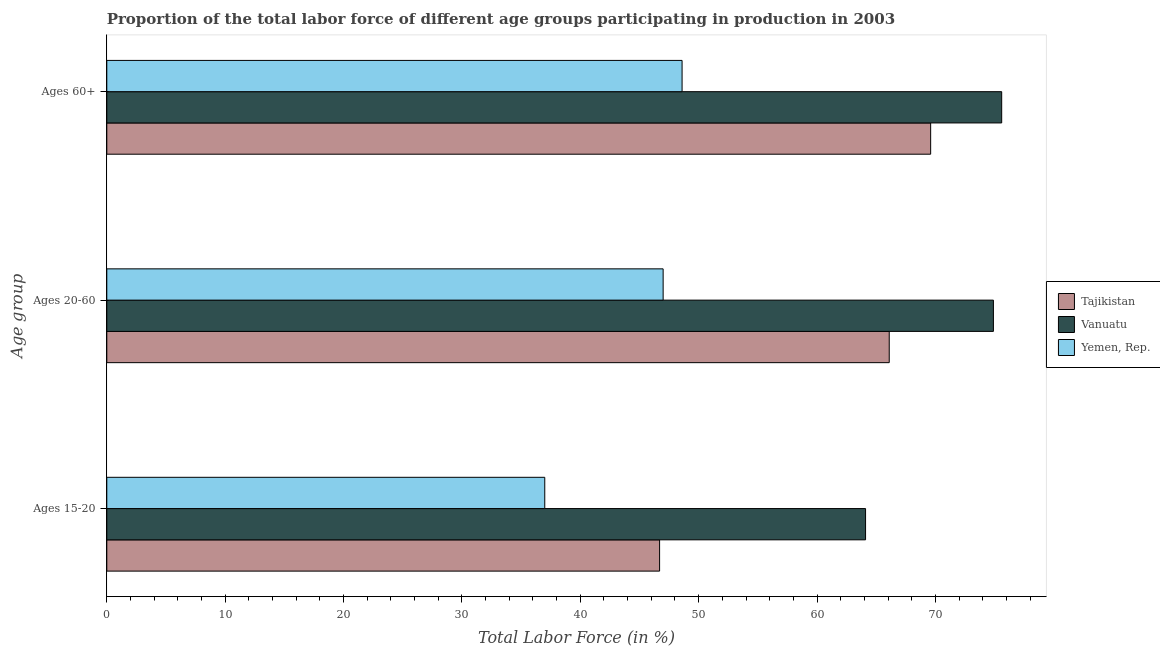How many different coloured bars are there?
Your response must be concise. 3. How many groups of bars are there?
Your answer should be compact. 3. What is the label of the 3rd group of bars from the top?
Ensure brevity in your answer.  Ages 15-20. What is the percentage of labor force above age 60 in Vanuatu?
Offer a terse response. 75.6. Across all countries, what is the maximum percentage of labor force within the age group 20-60?
Give a very brief answer. 74.9. Across all countries, what is the minimum percentage of labor force within the age group 20-60?
Give a very brief answer. 47. In which country was the percentage of labor force within the age group 20-60 maximum?
Offer a very short reply. Vanuatu. In which country was the percentage of labor force above age 60 minimum?
Provide a short and direct response. Yemen, Rep. What is the total percentage of labor force within the age group 20-60 in the graph?
Make the answer very short. 188. What is the difference between the percentage of labor force within the age group 15-20 in Tajikistan and that in Yemen, Rep.?
Your answer should be compact. 9.7. What is the difference between the percentage of labor force within the age group 20-60 in Yemen, Rep. and the percentage of labor force above age 60 in Vanuatu?
Provide a succinct answer. -28.6. What is the average percentage of labor force within the age group 15-20 per country?
Keep it short and to the point. 49.27. What is the difference between the percentage of labor force within the age group 15-20 and percentage of labor force within the age group 20-60 in Vanuatu?
Give a very brief answer. -10.8. In how many countries, is the percentage of labor force above age 60 greater than 62 %?
Your answer should be compact. 2. What is the ratio of the percentage of labor force above age 60 in Yemen, Rep. to that in Tajikistan?
Keep it short and to the point. 0.7. Is the percentage of labor force within the age group 20-60 in Yemen, Rep. less than that in Vanuatu?
Offer a terse response. Yes. What is the difference between the highest and the second highest percentage of labor force within the age group 20-60?
Your answer should be compact. 8.8. What is the difference between the highest and the lowest percentage of labor force within the age group 15-20?
Offer a terse response. 27.1. What does the 3rd bar from the top in Ages 20-60 represents?
Your answer should be very brief. Tajikistan. What does the 3rd bar from the bottom in Ages 20-60 represents?
Your answer should be very brief. Yemen, Rep. Is it the case that in every country, the sum of the percentage of labor force within the age group 15-20 and percentage of labor force within the age group 20-60 is greater than the percentage of labor force above age 60?
Your answer should be compact. Yes. How many countries are there in the graph?
Your response must be concise. 3. What is the difference between two consecutive major ticks on the X-axis?
Give a very brief answer. 10. Are the values on the major ticks of X-axis written in scientific E-notation?
Your response must be concise. No. Does the graph contain grids?
Your answer should be compact. No. How many legend labels are there?
Offer a terse response. 3. How are the legend labels stacked?
Keep it short and to the point. Vertical. What is the title of the graph?
Your answer should be compact. Proportion of the total labor force of different age groups participating in production in 2003. What is the label or title of the Y-axis?
Make the answer very short. Age group. What is the Total Labor Force (in %) of Tajikistan in Ages 15-20?
Provide a succinct answer. 46.7. What is the Total Labor Force (in %) of Vanuatu in Ages 15-20?
Keep it short and to the point. 64.1. What is the Total Labor Force (in %) in Tajikistan in Ages 20-60?
Provide a short and direct response. 66.1. What is the Total Labor Force (in %) of Vanuatu in Ages 20-60?
Give a very brief answer. 74.9. What is the Total Labor Force (in %) in Yemen, Rep. in Ages 20-60?
Your answer should be compact. 47. What is the Total Labor Force (in %) in Tajikistan in Ages 60+?
Your response must be concise. 69.6. What is the Total Labor Force (in %) in Vanuatu in Ages 60+?
Give a very brief answer. 75.6. What is the Total Labor Force (in %) in Yemen, Rep. in Ages 60+?
Your answer should be compact. 48.6. Across all Age group, what is the maximum Total Labor Force (in %) in Tajikistan?
Give a very brief answer. 69.6. Across all Age group, what is the maximum Total Labor Force (in %) in Vanuatu?
Your response must be concise. 75.6. Across all Age group, what is the maximum Total Labor Force (in %) in Yemen, Rep.?
Ensure brevity in your answer.  48.6. Across all Age group, what is the minimum Total Labor Force (in %) of Tajikistan?
Provide a succinct answer. 46.7. Across all Age group, what is the minimum Total Labor Force (in %) in Vanuatu?
Offer a terse response. 64.1. Across all Age group, what is the minimum Total Labor Force (in %) in Yemen, Rep.?
Your answer should be compact. 37. What is the total Total Labor Force (in %) in Tajikistan in the graph?
Offer a very short reply. 182.4. What is the total Total Labor Force (in %) in Vanuatu in the graph?
Give a very brief answer. 214.6. What is the total Total Labor Force (in %) in Yemen, Rep. in the graph?
Offer a very short reply. 132.6. What is the difference between the Total Labor Force (in %) in Tajikistan in Ages 15-20 and that in Ages 20-60?
Provide a succinct answer. -19.4. What is the difference between the Total Labor Force (in %) of Tajikistan in Ages 15-20 and that in Ages 60+?
Your response must be concise. -22.9. What is the difference between the Total Labor Force (in %) of Vanuatu in Ages 15-20 and that in Ages 60+?
Ensure brevity in your answer.  -11.5. What is the difference between the Total Labor Force (in %) in Yemen, Rep. in Ages 15-20 and that in Ages 60+?
Provide a succinct answer. -11.6. What is the difference between the Total Labor Force (in %) in Tajikistan in Ages 15-20 and the Total Labor Force (in %) in Vanuatu in Ages 20-60?
Keep it short and to the point. -28.2. What is the difference between the Total Labor Force (in %) in Tajikistan in Ages 15-20 and the Total Labor Force (in %) in Yemen, Rep. in Ages 20-60?
Keep it short and to the point. -0.3. What is the difference between the Total Labor Force (in %) of Tajikistan in Ages 15-20 and the Total Labor Force (in %) of Vanuatu in Ages 60+?
Your answer should be compact. -28.9. What is the difference between the Total Labor Force (in %) of Vanuatu in Ages 15-20 and the Total Labor Force (in %) of Yemen, Rep. in Ages 60+?
Provide a succinct answer. 15.5. What is the difference between the Total Labor Force (in %) of Vanuatu in Ages 20-60 and the Total Labor Force (in %) of Yemen, Rep. in Ages 60+?
Offer a terse response. 26.3. What is the average Total Labor Force (in %) in Tajikistan per Age group?
Provide a succinct answer. 60.8. What is the average Total Labor Force (in %) in Vanuatu per Age group?
Your answer should be very brief. 71.53. What is the average Total Labor Force (in %) in Yemen, Rep. per Age group?
Provide a short and direct response. 44.2. What is the difference between the Total Labor Force (in %) in Tajikistan and Total Labor Force (in %) in Vanuatu in Ages 15-20?
Provide a succinct answer. -17.4. What is the difference between the Total Labor Force (in %) in Tajikistan and Total Labor Force (in %) in Yemen, Rep. in Ages 15-20?
Provide a succinct answer. 9.7. What is the difference between the Total Labor Force (in %) in Vanuatu and Total Labor Force (in %) in Yemen, Rep. in Ages 15-20?
Keep it short and to the point. 27.1. What is the difference between the Total Labor Force (in %) in Vanuatu and Total Labor Force (in %) in Yemen, Rep. in Ages 20-60?
Ensure brevity in your answer.  27.9. What is the difference between the Total Labor Force (in %) in Tajikistan and Total Labor Force (in %) in Vanuatu in Ages 60+?
Ensure brevity in your answer.  -6. What is the difference between the Total Labor Force (in %) of Tajikistan and Total Labor Force (in %) of Yemen, Rep. in Ages 60+?
Provide a succinct answer. 21. What is the ratio of the Total Labor Force (in %) in Tajikistan in Ages 15-20 to that in Ages 20-60?
Offer a very short reply. 0.71. What is the ratio of the Total Labor Force (in %) in Vanuatu in Ages 15-20 to that in Ages 20-60?
Offer a very short reply. 0.86. What is the ratio of the Total Labor Force (in %) of Yemen, Rep. in Ages 15-20 to that in Ages 20-60?
Make the answer very short. 0.79. What is the ratio of the Total Labor Force (in %) of Tajikistan in Ages 15-20 to that in Ages 60+?
Keep it short and to the point. 0.67. What is the ratio of the Total Labor Force (in %) in Vanuatu in Ages 15-20 to that in Ages 60+?
Make the answer very short. 0.85. What is the ratio of the Total Labor Force (in %) of Yemen, Rep. in Ages 15-20 to that in Ages 60+?
Provide a succinct answer. 0.76. What is the ratio of the Total Labor Force (in %) in Tajikistan in Ages 20-60 to that in Ages 60+?
Keep it short and to the point. 0.95. What is the ratio of the Total Labor Force (in %) in Yemen, Rep. in Ages 20-60 to that in Ages 60+?
Give a very brief answer. 0.97. What is the difference between the highest and the second highest Total Labor Force (in %) of Tajikistan?
Offer a very short reply. 3.5. What is the difference between the highest and the second highest Total Labor Force (in %) of Yemen, Rep.?
Your answer should be compact. 1.6. What is the difference between the highest and the lowest Total Labor Force (in %) of Tajikistan?
Give a very brief answer. 22.9. 